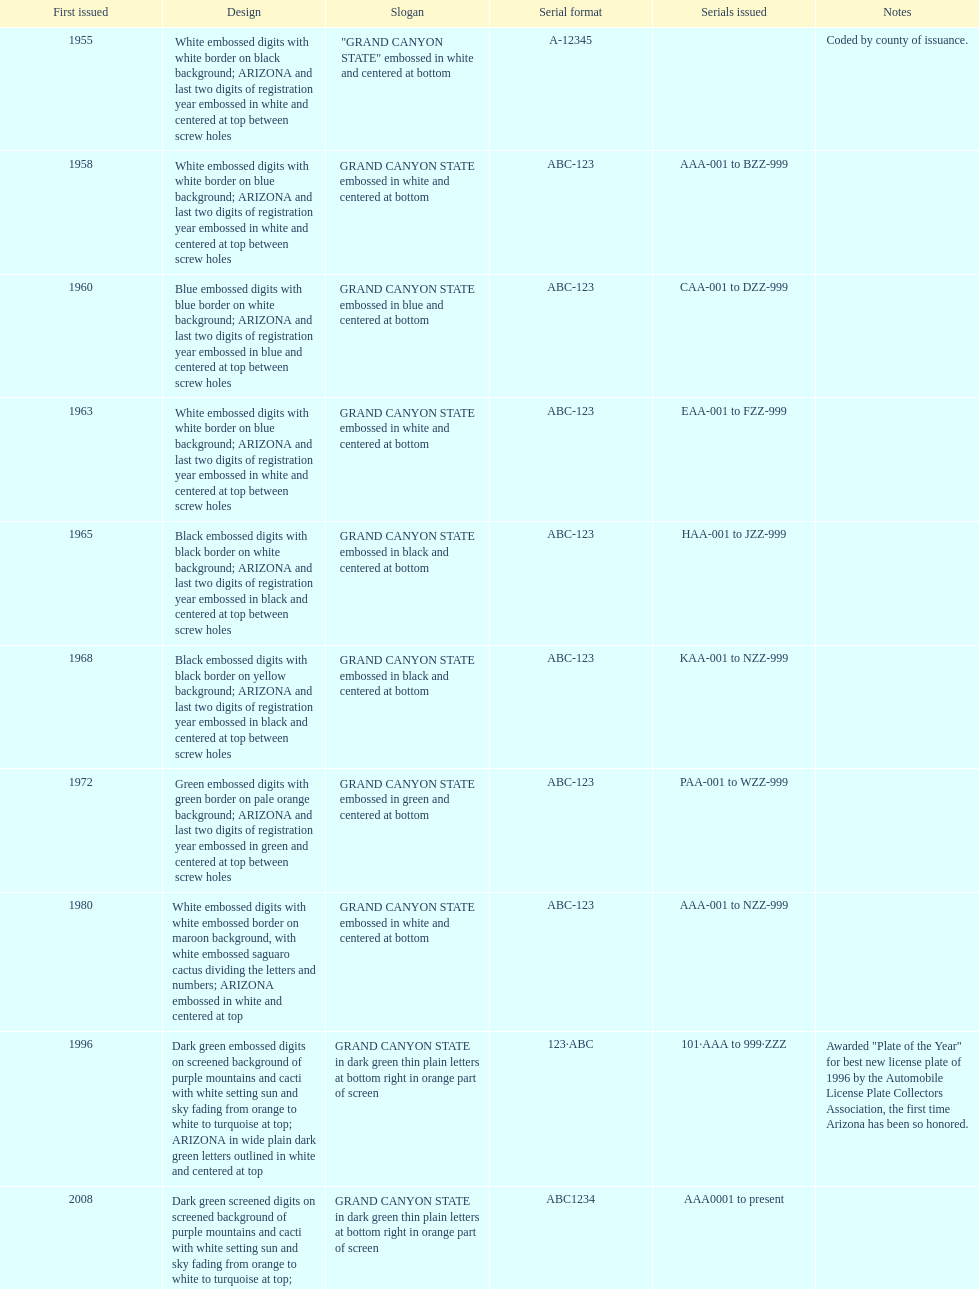In what year was the license plate with the least amount of characters featured? 1955. 